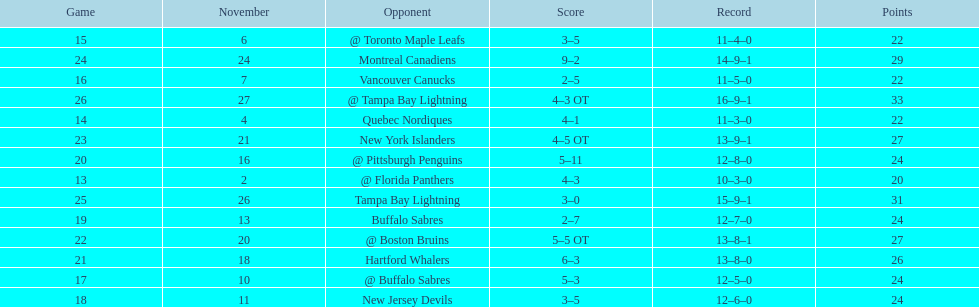What was the number of wins the philadelphia flyers had? 35. 